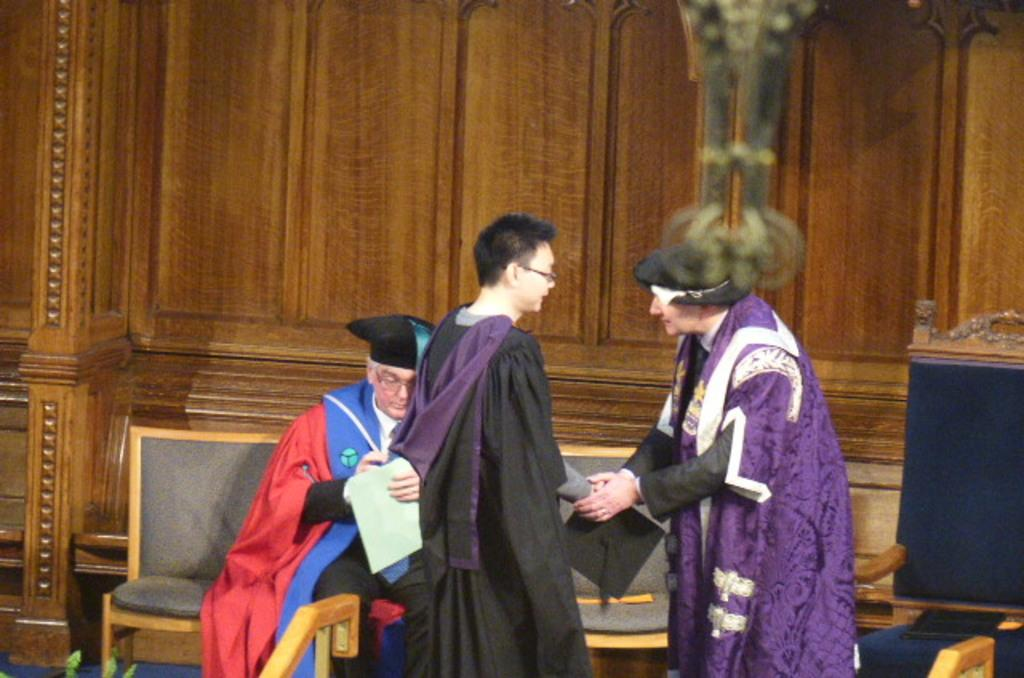How many people are in the image? There are two persons in the image. What are the two persons doing? The two persons are shaking hands. Can you describe the man in the background of the image? The man in the background is wearing spectacles and sitting on a chair. What type of system is being celebrated in the image? There is no system being celebrated in the image; the image shows two persons shaking hands. How many times did the person push the other person in the image? There is no pushing depicted in the image; the two persons are shaking hands. 